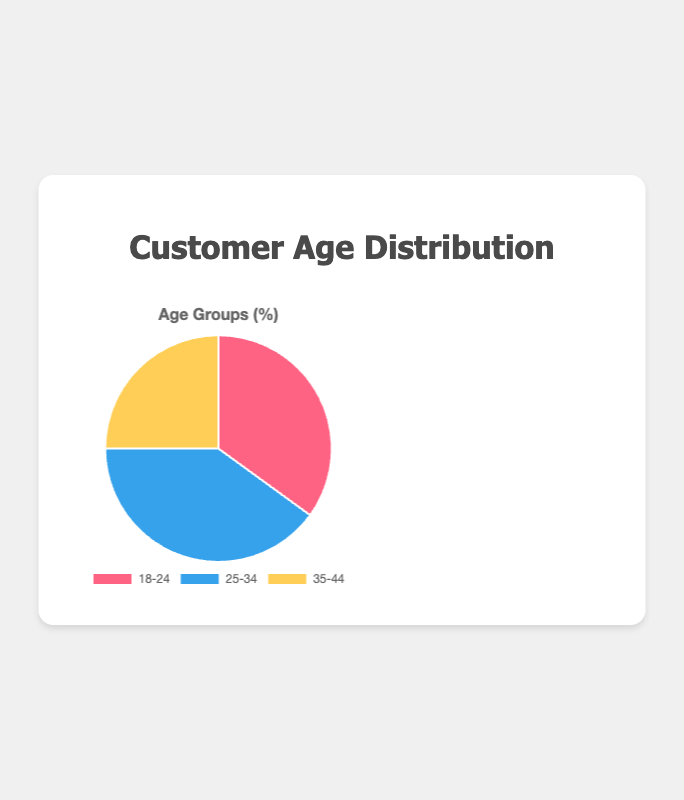What percentage of customers are in the '25-34' age group? The pie chart shows the percentage distribution of customers by age group. The '25-34' age group has a percentage value.
Answer: 40% Which age group constitutes the highest percentage of customers? By comparing the percentage values for each age group, we can see that the '25-34' age group has the highest percentage.
Answer: '25-34' What is the combined percentage of customers in the '18-24' and '35-44' age groups? Add the percentage values for '18-24' and '35-44'. 35% + 25% = 60%.
Answer: 60% How much higher is the percentage of customers in the '25-34' age group compared to the '35-44' age group? Subtract the percentage of the '35-44' age group from the '25-34' age group. 40% - 25% = 15%.
Answer: 15% By how much does the '18-24' age group's percentage fall short of the '25-34' age group's percentage? Subtract the percentage of the '18-24' age group from the '25-34' age group. 40% - 35% = 5%.
Answer: 5% What color represents the '18-24' age group in the pie chart? The pie chart uses different colors for each age group. The color corresponding to the '18-24' age group is displayed visually.
Answer: Red Which two age groups, when combined, make up the majority of the customers? Add the percentage values for each pair of age groups. The pairs '18-24' and '25-34' (35%+40%=75%) and '25-34' and '35-44' (40%+25%=65%) both exceed 50%. The highest combined percentage is for '18-24' and '25-34'.
Answer: '18-24' and '25-34' 